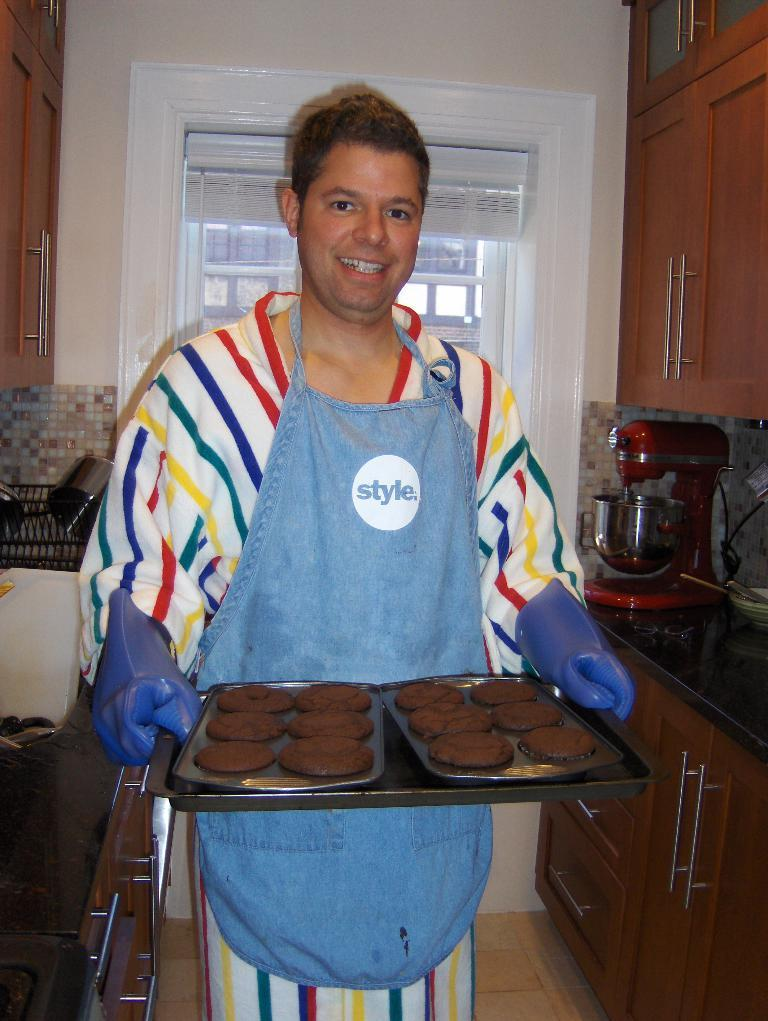<image>
Offer a succinct explanation of the picture presented. A man holding a tray of cookies has an apron that says style. 